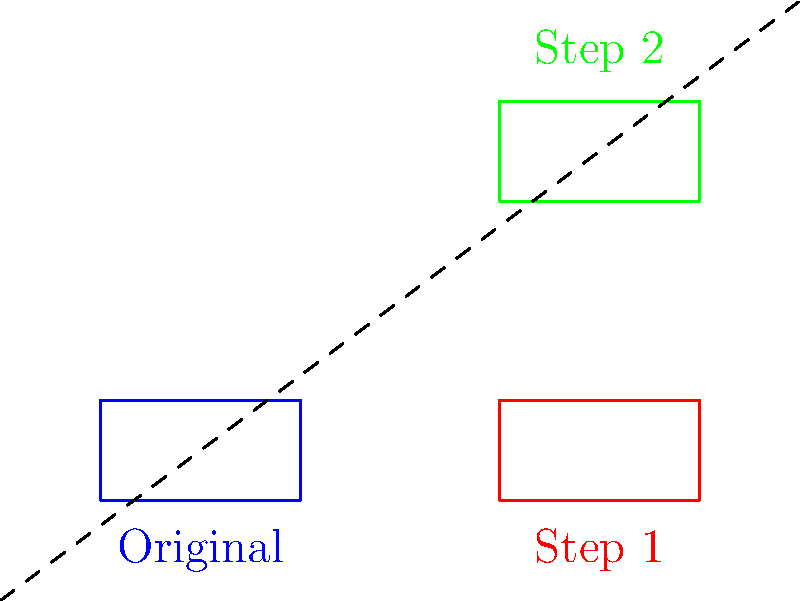During your time on the force, you often had to analyze the movement of police vehicles. In the diagram above, a police car shape undergoes two transformations from its original position (blue) to its final position (green). Identify the sequence of transformations applied to reach the final position. Let's analyze the transformations step-by-step:

1. From the original position (blue) to Step 1 (red):
   - The shape moves 4 units to the right.
   - This is a translation of 4 units in the positive x-direction.

2. From Step 1 (red) to Step 2 (green):
   - The shape moves 3 units up.
   - This is a translation of 3 units in the positive y-direction.

3. Observing the overall transformation:
   - The shape maintains its size and orientation throughout.
   - It only changes its position on the plane.

4. The dashed line represents the total displacement of the shape from its original position to the final position.

Therefore, the sequence of transformations is:
1. Translation 4 units right
2. Translation 3 units up

These can be combined into a single translation of (4, 3) in vector notation.
Answer: Translation (4, 3) 